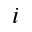Convert formula to latex. <formula><loc_0><loc_0><loc_500><loc_500>i</formula> 